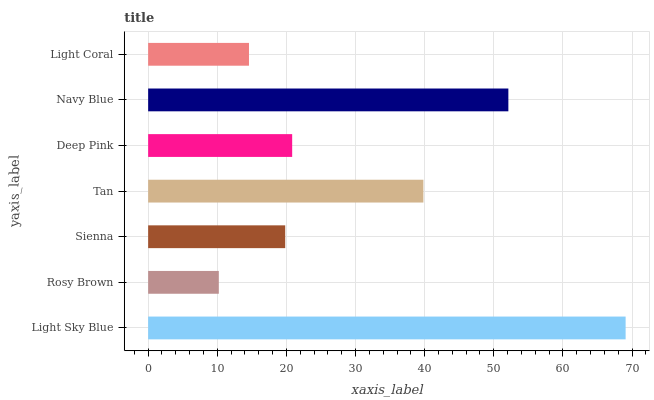Is Rosy Brown the minimum?
Answer yes or no. Yes. Is Light Sky Blue the maximum?
Answer yes or no. Yes. Is Sienna the minimum?
Answer yes or no. No. Is Sienna the maximum?
Answer yes or no. No. Is Sienna greater than Rosy Brown?
Answer yes or no. Yes. Is Rosy Brown less than Sienna?
Answer yes or no. Yes. Is Rosy Brown greater than Sienna?
Answer yes or no. No. Is Sienna less than Rosy Brown?
Answer yes or no. No. Is Deep Pink the high median?
Answer yes or no. Yes. Is Deep Pink the low median?
Answer yes or no. Yes. Is Rosy Brown the high median?
Answer yes or no. No. Is Rosy Brown the low median?
Answer yes or no. No. 